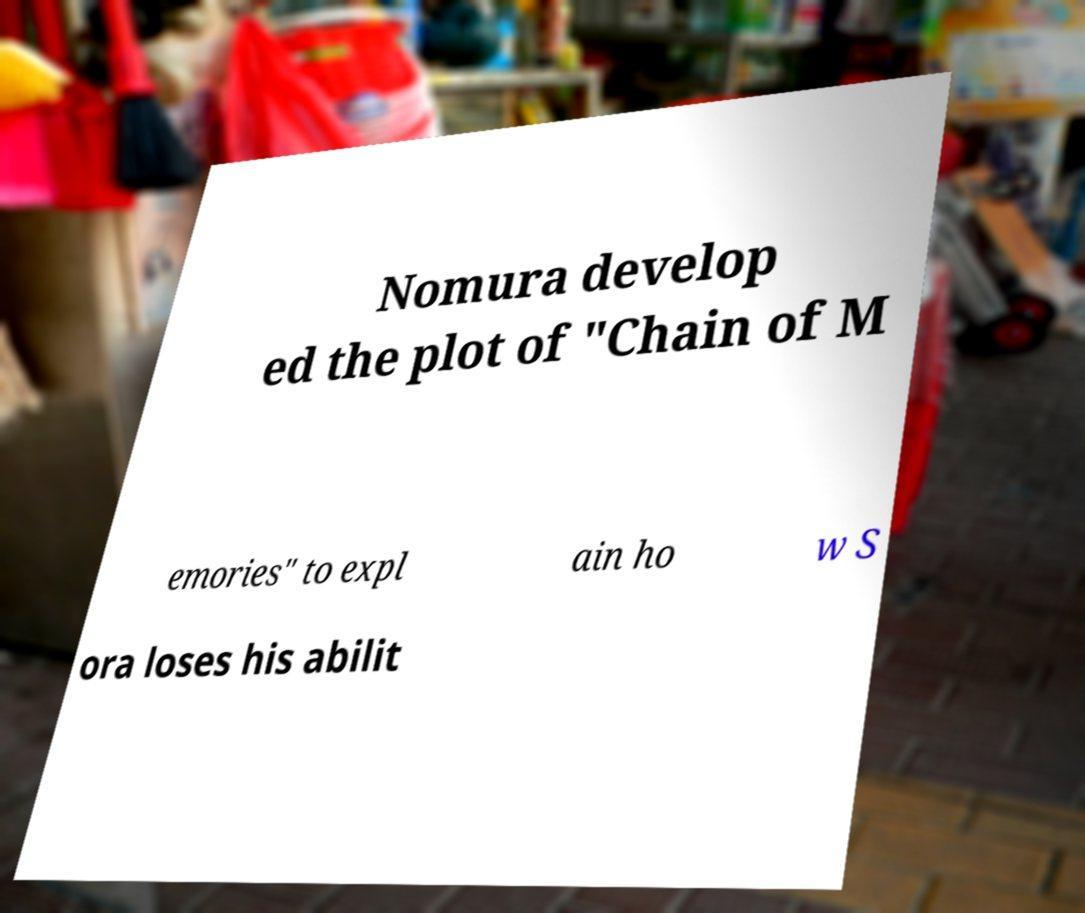Please identify and transcribe the text found in this image. Nomura develop ed the plot of "Chain of M emories" to expl ain ho w S ora loses his abilit 